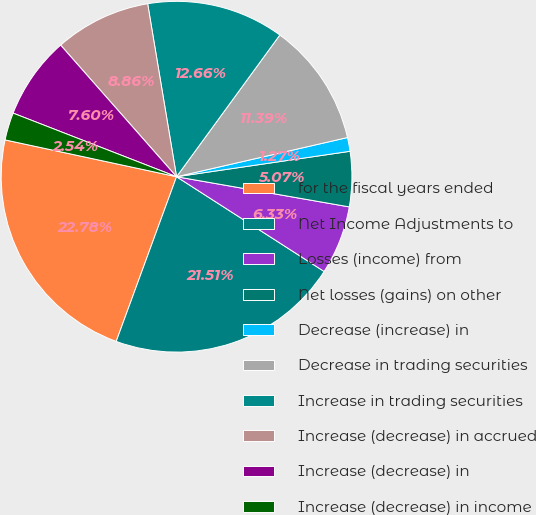Convert chart to OTSL. <chart><loc_0><loc_0><loc_500><loc_500><pie_chart><fcel>for the fiscal years ended<fcel>Net Income Adjustments to<fcel>Losses (income) from<fcel>Net losses (gains) on other<fcel>Decrease (increase) in<fcel>Decrease in trading securities<fcel>Increase in trading securities<fcel>Increase (decrease) in accrued<fcel>Increase (decrease) in<fcel>Increase (decrease) in income<nl><fcel>22.78%<fcel>21.51%<fcel>6.33%<fcel>5.07%<fcel>1.27%<fcel>11.39%<fcel>12.66%<fcel>8.86%<fcel>7.6%<fcel>2.54%<nl></chart> 